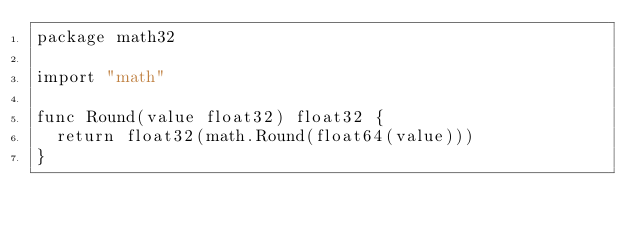Convert code to text. <code><loc_0><loc_0><loc_500><loc_500><_Go_>package math32

import "math"

func Round(value float32) float32 {
	return float32(math.Round(float64(value)))
}
</code> 